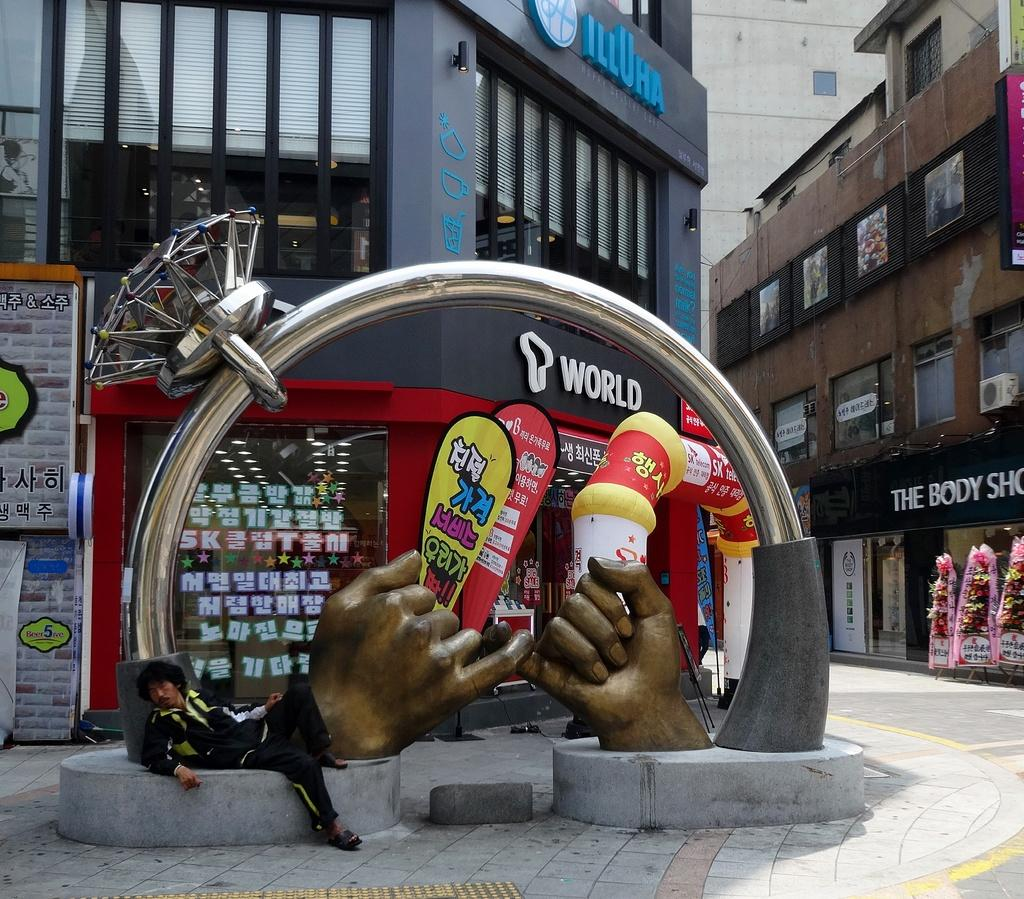Who or what is present in the image? There is a person in the image. What is the person wearing? The person is wearing a black dress. What else can be seen in the image besides the person? There is a sculpture in the image. What can be seen in the distance in the image? There are buildings in the background of the image. What type of camera is the person using to take a picture in the image? There is no camera visible in the image, and the person is not taking a picture. 